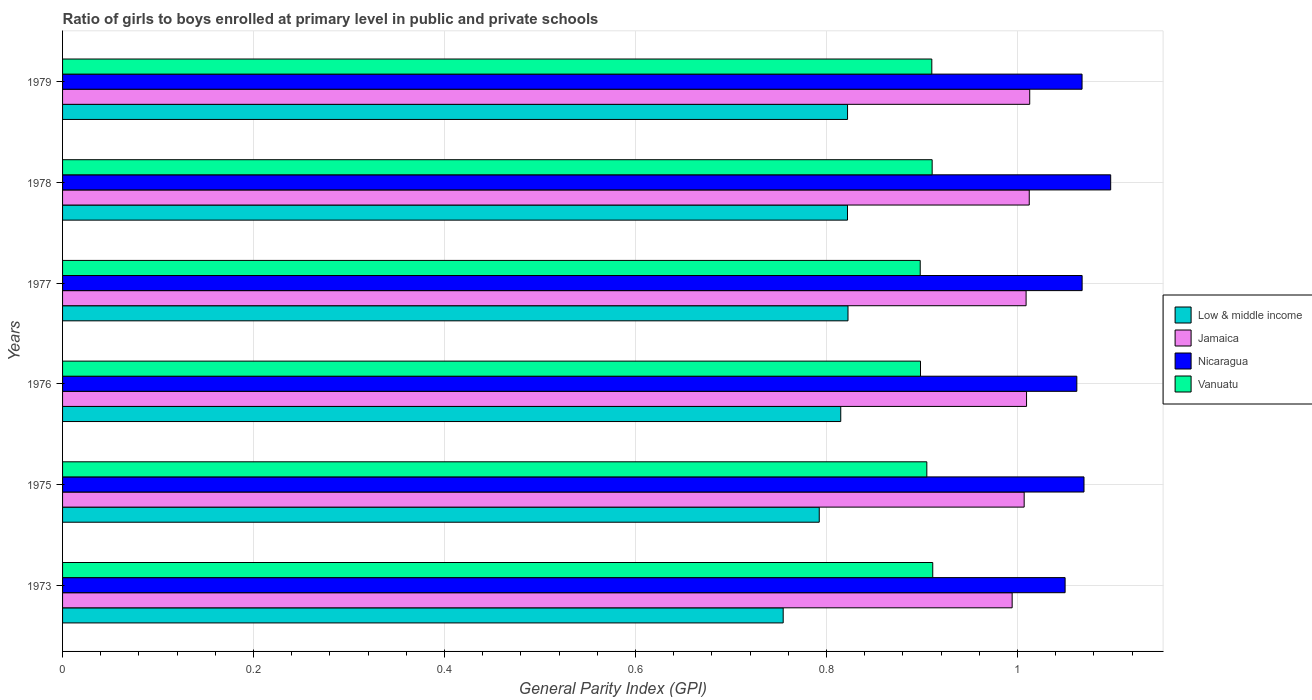How many different coloured bars are there?
Your response must be concise. 4. How many bars are there on the 1st tick from the top?
Ensure brevity in your answer.  4. What is the label of the 3rd group of bars from the top?
Keep it short and to the point. 1977. In how many cases, is the number of bars for a given year not equal to the number of legend labels?
Provide a short and direct response. 0. What is the general parity index in Nicaragua in 1975?
Offer a terse response. 1.07. Across all years, what is the maximum general parity index in Jamaica?
Offer a very short reply. 1.01. Across all years, what is the minimum general parity index in Low & middle income?
Your answer should be compact. 0.75. In which year was the general parity index in Vanuatu maximum?
Your answer should be very brief. 1973. In which year was the general parity index in Vanuatu minimum?
Make the answer very short. 1977. What is the total general parity index in Nicaragua in the graph?
Your answer should be compact. 6.41. What is the difference between the general parity index in Nicaragua in 1973 and that in 1975?
Ensure brevity in your answer.  -0.02. What is the difference between the general parity index in Vanuatu in 1979 and the general parity index in Low & middle income in 1976?
Your answer should be very brief. 0.1. What is the average general parity index in Low & middle income per year?
Keep it short and to the point. 0.8. In the year 1975, what is the difference between the general parity index in Nicaragua and general parity index in Jamaica?
Offer a terse response. 0.06. What is the ratio of the general parity index in Low & middle income in 1975 to that in 1977?
Provide a succinct answer. 0.96. Is the difference between the general parity index in Nicaragua in 1975 and 1977 greater than the difference between the general parity index in Jamaica in 1975 and 1977?
Give a very brief answer. Yes. What is the difference between the highest and the second highest general parity index in Jamaica?
Your answer should be very brief. 0. What is the difference between the highest and the lowest general parity index in Low & middle income?
Offer a very short reply. 0.07. In how many years, is the general parity index in Nicaragua greater than the average general parity index in Nicaragua taken over all years?
Your answer should be compact. 2. Is the sum of the general parity index in Vanuatu in 1976 and 1977 greater than the maximum general parity index in Jamaica across all years?
Your answer should be compact. Yes. What does the 1st bar from the top in 1979 represents?
Offer a very short reply. Vanuatu. How many bars are there?
Offer a terse response. 24. Are all the bars in the graph horizontal?
Provide a succinct answer. Yes. How many years are there in the graph?
Your answer should be very brief. 6. Does the graph contain any zero values?
Provide a short and direct response. No. How many legend labels are there?
Ensure brevity in your answer.  4. How are the legend labels stacked?
Ensure brevity in your answer.  Vertical. What is the title of the graph?
Provide a succinct answer. Ratio of girls to boys enrolled at primary level in public and private schools. What is the label or title of the X-axis?
Give a very brief answer. General Parity Index (GPI). What is the General Parity Index (GPI) of Low & middle income in 1973?
Offer a terse response. 0.75. What is the General Parity Index (GPI) of Jamaica in 1973?
Provide a short and direct response. 0.99. What is the General Parity Index (GPI) in Nicaragua in 1973?
Your answer should be compact. 1.05. What is the General Parity Index (GPI) of Vanuatu in 1973?
Make the answer very short. 0.91. What is the General Parity Index (GPI) in Low & middle income in 1975?
Your answer should be very brief. 0.79. What is the General Parity Index (GPI) in Jamaica in 1975?
Provide a succinct answer. 1.01. What is the General Parity Index (GPI) in Nicaragua in 1975?
Make the answer very short. 1.07. What is the General Parity Index (GPI) in Vanuatu in 1975?
Provide a short and direct response. 0.91. What is the General Parity Index (GPI) of Low & middle income in 1976?
Keep it short and to the point. 0.81. What is the General Parity Index (GPI) of Jamaica in 1976?
Your response must be concise. 1.01. What is the General Parity Index (GPI) in Nicaragua in 1976?
Your response must be concise. 1.06. What is the General Parity Index (GPI) of Vanuatu in 1976?
Your answer should be compact. 0.9. What is the General Parity Index (GPI) in Low & middle income in 1977?
Provide a short and direct response. 0.82. What is the General Parity Index (GPI) in Jamaica in 1977?
Provide a succinct answer. 1.01. What is the General Parity Index (GPI) in Nicaragua in 1977?
Your response must be concise. 1.07. What is the General Parity Index (GPI) of Vanuatu in 1977?
Your response must be concise. 0.9. What is the General Parity Index (GPI) in Low & middle income in 1978?
Make the answer very short. 0.82. What is the General Parity Index (GPI) in Jamaica in 1978?
Offer a terse response. 1.01. What is the General Parity Index (GPI) of Nicaragua in 1978?
Give a very brief answer. 1.1. What is the General Parity Index (GPI) in Vanuatu in 1978?
Provide a short and direct response. 0.91. What is the General Parity Index (GPI) in Low & middle income in 1979?
Keep it short and to the point. 0.82. What is the General Parity Index (GPI) of Jamaica in 1979?
Your answer should be very brief. 1.01. What is the General Parity Index (GPI) in Nicaragua in 1979?
Offer a terse response. 1.07. What is the General Parity Index (GPI) in Vanuatu in 1979?
Your response must be concise. 0.91. Across all years, what is the maximum General Parity Index (GPI) in Low & middle income?
Offer a very short reply. 0.82. Across all years, what is the maximum General Parity Index (GPI) of Jamaica?
Keep it short and to the point. 1.01. Across all years, what is the maximum General Parity Index (GPI) in Nicaragua?
Provide a short and direct response. 1.1. Across all years, what is the maximum General Parity Index (GPI) of Vanuatu?
Ensure brevity in your answer.  0.91. Across all years, what is the minimum General Parity Index (GPI) in Low & middle income?
Your response must be concise. 0.75. Across all years, what is the minimum General Parity Index (GPI) of Jamaica?
Offer a very short reply. 0.99. Across all years, what is the minimum General Parity Index (GPI) in Nicaragua?
Provide a short and direct response. 1.05. Across all years, what is the minimum General Parity Index (GPI) of Vanuatu?
Your answer should be very brief. 0.9. What is the total General Parity Index (GPI) of Low & middle income in the graph?
Your answer should be very brief. 4.83. What is the total General Parity Index (GPI) in Jamaica in the graph?
Give a very brief answer. 6.05. What is the total General Parity Index (GPI) in Nicaragua in the graph?
Your response must be concise. 6.41. What is the total General Parity Index (GPI) of Vanuatu in the graph?
Your response must be concise. 5.43. What is the difference between the General Parity Index (GPI) of Low & middle income in 1973 and that in 1975?
Keep it short and to the point. -0.04. What is the difference between the General Parity Index (GPI) of Jamaica in 1973 and that in 1975?
Your response must be concise. -0.01. What is the difference between the General Parity Index (GPI) of Nicaragua in 1973 and that in 1975?
Offer a terse response. -0.02. What is the difference between the General Parity Index (GPI) of Vanuatu in 1973 and that in 1975?
Your answer should be very brief. 0.01. What is the difference between the General Parity Index (GPI) in Low & middle income in 1973 and that in 1976?
Offer a very short reply. -0.06. What is the difference between the General Parity Index (GPI) in Jamaica in 1973 and that in 1976?
Make the answer very short. -0.02. What is the difference between the General Parity Index (GPI) in Nicaragua in 1973 and that in 1976?
Ensure brevity in your answer.  -0.01. What is the difference between the General Parity Index (GPI) in Vanuatu in 1973 and that in 1976?
Provide a short and direct response. 0.01. What is the difference between the General Parity Index (GPI) of Low & middle income in 1973 and that in 1977?
Offer a terse response. -0.07. What is the difference between the General Parity Index (GPI) in Jamaica in 1973 and that in 1977?
Ensure brevity in your answer.  -0.01. What is the difference between the General Parity Index (GPI) in Nicaragua in 1973 and that in 1977?
Ensure brevity in your answer.  -0.02. What is the difference between the General Parity Index (GPI) in Vanuatu in 1973 and that in 1977?
Your answer should be very brief. 0.01. What is the difference between the General Parity Index (GPI) in Low & middle income in 1973 and that in 1978?
Your response must be concise. -0.07. What is the difference between the General Parity Index (GPI) in Jamaica in 1973 and that in 1978?
Give a very brief answer. -0.02. What is the difference between the General Parity Index (GPI) in Nicaragua in 1973 and that in 1978?
Your answer should be very brief. -0.05. What is the difference between the General Parity Index (GPI) of Vanuatu in 1973 and that in 1978?
Your response must be concise. 0. What is the difference between the General Parity Index (GPI) of Low & middle income in 1973 and that in 1979?
Your response must be concise. -0.07. What is the difference between the General Parity Index (GPI) of Jamaica in 1973 and that in 1979?
Keep it short and to the point. -0.02. What is the difference between the General Parity Index (GPI) of Nicaragua in 1973 and that in 1979?
Offer a very short reply. -0.02. What is the difference between the General Parity Index (GPI) in Low & middle income in 1975 and that in 1976?
Make the answer very short. -0.02. What is the difference between the General Parity Index (GPI) in Jamaica in 1975 and that in 1976?
Your answer should be very brief. -0. What is the difference between the General Parity Index (GPI) of Nicaragua in 1975 and that in 1976?
Offer a terse response. 0.01. What is the difference between the General Parity Index (GPI) of Vanuatu in 1975 and that in 1976?
Your response must be concise. 0.01. What is the difference between the General Parity Index (GPI) of Low & middle income in 1975 and that in 1977?
Make the answer very short. -0.03. What is the difference between the General Parity Index (GPI) of Jamaica in 1975 and that in 1977?
Provide a succinct answer. -0. What is the difference between the General Parity Index (GPI) of Nicaragua in 1975 and that in 1977?
Provide a succinct answer. 0. What is the difference between the General Parity Index (GPI) of Vanuatu in 1975 and that in 1977?
Provide a short and direct response. 0.01. What is the difference between the General Parity Index (GPI) of Low & middle income in 1975 and that in 1978?
Give a very brief answer. -0.03. What is the difference between the General Parity Index (GPI) of Jamaica in 1975 and that in 1978?
Your response must be concise. -0.01. What is the difference between the General Parity Index (GPI) of Nicaragua in 1975 and that in 1978?
Ensure brevity in your answer.  -0.03. What is the difference between the General Parity Index (GPI) in Vanuatu in 1975 and that in 1978?
Offer a terse response. -0.01. What is the difference between the General Parity Index (GPI) of Low & middle income in 1975 and that in 1979?
Offer a very short reply. -0.03. What is the difference between the General Parity Index (GPI) of Jamaica in 1975 and that in 1979?
Ensure brevity in your answer.  -0.01. What is the difference between the General Parity Index (GPI) in Nicaragua in 1975 and that in 1979?
Provide a short and direct response. 0. What is the difference between the General Parity Index (GPI) of Vanuatu in 1975 and that in 1979?
Provide a short and direct response. -0.01. What is the difference between the General Parity Index (GPI) of Low & middle income in 1976 and that in 1977?
Make the answer very short. -0.01. What is the difference between the General Parity Index (GPI) in Nicaragua in 1976 and that in 1977?
Provide a short and direct response. -0.01. What is the difference between the General Parity Index (GPI) in Vanuatu in 1976 and that in 1977?
Your answer should be very brief. 0. What is the difference between the General Parity Index (GPI) in Low & middle income in 1976 and that in 1978?
Your answer should be compact. -0.01. What is the difference between the General Parity Index (GPI) in Jamaica in 1976 and that in 1978?
Offer a very short reply. -0. What is the difference between the General Parity Index (GPI) in Nicaragua in 1976 and that in 1978?
Offer a very short reply. -0.04. What is the difference between the General Parity Index (GPI) of Vanuatu in 1976 and that in 1978?
Make the answer very short. -0.01. What is the difference between the General Parity Index (GPI) of Low & middle income in 1976 and that in 1979?
Ensure brevity in your answer.  -0.01. What is the difference between the General Parity Index (GPI) in Jamaica in 1976 and that in 1979?
Keep it short and to the point. -0. What is the difference between the General Parity Index (GPI) in Nicaragua in 1976 and that in 1979?
Keep it short and to the point. -0.01. What is the difference between the General Parity Index (GPI) of Vanuatu in 1976 and that in 1979?
Ensure brevity in your answer.  -0.01. What is the difference between the General Parity Index (GPI) of Jamaica in 1977 and that in 1978?
Keep it short and to the point. -0. What is the difference between the General Parity Index (GPI) in Nicaragua in 1977 and that in 1978?
Your answer should be very brief. -0.03. What is the difference between the General Parity Index (GPI) of Vanuatu in 1977 and that in 1978?
Your response must be concise. -0.01. What is the difference between the General Parity Index (GPI) in Jamaica in 1977 and that in 1979?
Ensure brevity in your answer.  -0. What is the difference between the General Parity Index (GPI) of Nicaragua in 1977 and that in 1979?
Offer a terse response. 0. What is the difference between the General Parity Index (GPI) in Vanuatu in 1977 and that in 1979?
Provide a succinct answer. -0.01. What is the difference between the General Parity Index (GPI) of Low & middle income in 1978 and that in 1979?
Your response must be concise. -0. What is the difference between the General Parity Index (GPI) in Jamaica in 1978 and that in 1979?
Your response must be concise. -0. What is the difference between the General Parity Index (GPI) in Nicaragua in 1978 and that in 1979?
Your answer should be very brief. 0.03. What is the difference between the General Parity Index (GPI) in Low & middle income in 1973 and the General Parity Index (GPI) in Jamaica in 1975?
Keep it short and to the point. -0.25. What is the difference between the General Parity Index (GPI) of Low & middle income in 1973 and the General Parity Index (GPI) of Nicaragua in 1975?
Give a very brief answer. -0.32. What is the difference between the General Parity Index (GPI) in Low & middle income in 1973 and the General Parity Index (GPI) in Vanuatu in 1975?
Offer a terse response. -0.15. What is the difference between the General Parity Index (GPI) in Jamaica in 1973 and the General Parity Index (GPI) in Nicaragua in 1975?
Offer a terse response. -0.08. What is the difference between the General Parity Index (GPI) in Jamaica in 1973 and the General Parity Index (GPI) in Vanuatu in 1975?
Provide a short and direct response. 0.09. What is the difference between the General Parity Index (GPI) of Nicaragua in 1973 and the General Parity Index (GPI) of Vanuatu in 1975?
Ensure brevity in your answer.  0.14. What is the difference between the General Parity Index (GPI) in Low & middle income in 1973 and the General Parity Index (GPI) in Jamaica in 1976?
Give a very brief answer. -0.25. What is the difference between the General Parity Index (GPI) in Low & middle income in 1973 and the General Parity Index (GPI) in Nicaragua in 1976?
Provide a short and direct response. -0.31. What is the difference between the General Parity Index (GPI) of Low & middle income in 1973 and the General Parity Index (GPI) of Vanuatu in 1976?
Your answer should be very brief. -0.14. What is the difference between the General Parity Index (GPI) in Jamaica in 1973 and the General Parity Index (GPI) in Nicaragua in 1976?
Give a very brief answer. -0.07. What is the difference between the General Parity Index (GPI) in Jamaica in 1973 and the General Parity Index (GPI) in Vanuatu in 1976?
Offer a terse response. 0.1. What is the difference between the General Parity Index (GPI) in Nicaragua in 1973 and the General Parity Index (GPI) in Vanuatu in 1976?
Your response must be concise. 0.15. What is the difference between the General Parity Index (GPI) of Low & middle income in 1973 and the General Parity Index (GPI) of Jamaica in 1977?
Your answer should be compact. -0.25. What is the difference between the General Parity Index (GPI) of Low & middle income in 1973 and the General Parity Index (GPI) of Nicaragua in 1977?
Provide a succinct answer. -0.31. What is the difference between the General Parity Index (GPI) in Low & middle income in 1973 and the General Parity Index (GPI) in Vanuatu in 1977?
Your answer should be very brief. -0.14. What is the difference between the General Parity Index (GPI) of Jamaica in 1973 and the General Parity Index (GPI) of Nicaragua in 1977?
Your answer should be very brief. -0.07. What is the difference between the General Parity Index (GPI) in Jamaica in 1973 and the General Parity Index (GPI) in Vanuatu in 1977?
Your response must be concise. 0.1. What is the difference between the General Parity Index (GPI) of Nicaragua in 1973 and the General Parity Index (GPI) of Vanuatu in 1977?
Give a very brief answer. 0.15. What is the difference between the General Parity Index (GPI) of Low & middle income in 1973 and the General Parity Index (GPI) of Jamaica in 1978?
Provide a short and direct response. -0.26. What is the difference between the General Parity Index (GPI) of Low & middle income in 1973 and the General Parity Index (GPI) of Nicaragua in 1978?
Your answer should be very brief. -0.34. What is the difference between the General Parity Index (GPI) of Low & middle income in 1973 and the General Parity Index (GPI) of Vanuatu in 1978?
Keep it short and to the point. -0.16. What is the difference between the General Parity Index (GPI) in Jamaica in 1973 and the General Parity Index (GPI) in Nicaragua in 1978?
Provide a succinct answer. -0.1. What is the difference between the General Parity Index (GPI) of Jamaica in 1973 and the General Parity Index (GPI) of Vanuatu in 1978?
Offer a very short reply. 0.08. What is the difference between the General Parity Index (GPI) of Nicaragua in 1973 and the General Parity Index (GPI) of Vanuatu in 1978?
Your response must be concise. 0.14. What is the difference between the General Parity Index (GPI) of Low & middle income in 1973 and the General Parity Index (GPI) of Jamaica in 1979?
Offer a very short reply. -0.26. What is the difference between the General Parity Index (GPI) in Low & middle income in 1973 and the General Parity Index (GPI) in Nicaragua in 1979?
Make the answer very short. -0.31. What is the difference between the General Parity Index (GPI) in Low & middle income in 1973 and the General Parity Index (GPI) in Vanuatu in 1979?
Provide a short and direct response. -0.16. What is the difference between the General Parity Index (GPI) of Jamaica in 1973 and the General Parity Index (GPI) of Nicaragua in 1979?
Give a very brief answer. -0.07. What is the difference between the General Parity Index (GPI) in Jamaica in 1973 and the General Parity Index (GPI) in Vanuatu in 1979?
Provide a short and direct response. 0.08. What is the difference between the General Parity Index (GPI) in Nicaragua in 1973 and the General Parity Index (GPI) in Vanuatu in 1979?
Provide a short and direct response. 0.14. What is the difference between the General Parity Index (GPI) of Low & middle income in 1975 and the General Parity Index (GPI) of Jamaica in 1976?
Your answer should be very brief. -0.22. What is the difference between the General Parity Index (GPI) in Low & middle income in 1975 and the General Parity Index (GPI) in Nicaragua in 1976?
Your answer should be compact. -0.27. What is the difference between the General Parity Index (GPI) in Low & middle income in 1975 and the General Parity Index (GPI) in Vanuatu in 1976?
Make the answer very short. -0.11. What is the difference between the General Parity Index (GPI) of Jamaica in 1975 and the General Parity Index (GPI) of Nicaragua in 1976?
Offer a terse response. -0.06. What is the difference between the General Parity Index (GPI) of Jamaica in 1975 and the General Parity Index (GPI) of Vanuatu in 1976?
Make the answer very short. 0.11. What is the difference between the General Parity Index (GPI) in Nicaragua in 1975 and the General Parity Index (GPI) in Vanuatu in 1976?
Offer a very short reply. 0.17. What is the difference between the General Parity Index (GPI) in Low & middle income in 1975 and the General Parity Index (GPI) in Jamaica in 1977?
Keep it short and to the point. -0.22. What is the difference between the General Parity Index (GPI) in Low & middle income in 1975 and the General Parity Index (GPI) in Nicaragua in 1977?
Keep it short and to the point. -0.28. What is the difference between the General Parity Index (GPI) of Low & middle income in 1975 and the General Parity Index (GPI) of Vanuatu in 1977?
Offer a terse response. -0.11. What is the difference between the General Parity Index (GPI) in Jamaica in 1975 and the General Parity Index (GPI) in Nicaragua in 1977?
Keep it short and to the point. -0.06. What is the difference between the General Parity Index (GPI) in Jamaica in 1975 and the General Parity Index (GPI) in Vanuatu in 1977?
Give a very brief answer. 0.11. What is the difference between the General Parity Index (GPI) in Nicaragua in 1975 and the General Parity Index (GPI) in Vanuatu in 1977?
Ensure brevity in your answer.  0.17. What is the difference between the General Parity Index (GPI) of Low & middle income in 1975 and the General Parity Index (GPI) of Jamaica in 1978?
Provide a succinct answer. -0.22. What is the difference between the General Parity Index (GPI) of Low & middle income in 1975 and the General Parity Index (GPI) of Nicaragua in 1978?
Provide a succinct answer. -0.31. What is the difference between the General Parity Index (GPI) in Low & middle income in 1975 and the General Parity Index (GPI) in Vanuatu in 1978?
Ensure brevity in your answer.  -0.12. What is the difference between the General Parity Index (GPI) of Jamaica in 1975 and the General Parity Index (GPI) of Nicaragua in 1978?
Give a very brief answer. -0.09. What is the difference between the General Parity Index (GPI) in Jamaica in 1975 and the General Parity Index (GPI) in Vanuatu in 1978?
Make the answer very short. 0.1. What is the difference between the General Parity Index (GPI) in Nicaragua in 1975 and the General Parity Index (GPI) in Vanuatu in 1978?
Keep it short and to the point. 0.16. What is the difference between the General Parity Index (GPI) in Low & middle income in 1975 and the General Parity Index (GPI) in Jamaica in 1979?
Provide a succinct answer. -0.22. What is the difference between the General Parity Index (GPI) of Low & middle income in 1975 and the General Parity Index (GPI) of Nicaragua in 1979?
Your response must be concise. -0.28. What is the difference between the General Parity Index (GPI) of Low & middle income in 1975 and the General Parity Index (GPI) of Vanuatu in 1979?
Provide a short and direct response. -0.12. What is the difference between the General Parity Index (GPI) in Jamaica in 1975 and the General Parity Index (GPI) in Nicaragua in 1979?
Your answer should be very brief. -0.06. What is the difference between the General Parity Index (GPI) in Jamaica in 1975 and the General Parity Index (GPI) in Vanuatu in 1979?
Keep it short and to the point. 0.1. What is the difference between the General Parity Index (GPI) in Nicaragua in 1975 and the General Parity Index (GPI) in Vanuatu in 1979?
Your answer should be very brief. 0.16. What is the difference between the General Parity Index (GPI) of Low & middle income in 1976 and the General Parity Index (GPI) of Jamaica in 1977?
Your response must be concise. -0.19. What is the difference between the General Parity Index (GPI) in Low & middle income in 1976 and the General Parity Index (GPI) in Nicaragua in 1977?
Provide a short and direct response. -0.25. What is the difference between the General Parity Index (GPI) of Low & middle income in 1976 and the General Parity Index (GPI) of Vanuatu in 1977?
Keep it short and to the point. -0.08. What is the difference between the General Parity Index (GPI) in Jamaica in 1976 and the General Parity Index (GPI) in Nicaragua in 1977?
Give a very brief answer. -0.06. What is the difference between the General Parity Index (GPI) of Jamaica in 1976 and the General Parity Index (GPI) of Vanuatu in 1977?
Your answer should be very brief. 0.11. What is the difference between the General Parity Index (GPI) of Nicaragua in 1976 and the General Parity Index (GPI) of Vanuatu in 1977?
Your answer should be very brief. 0.16. What is the difference between the General Parity Index (GPI) of Low & middle income in 1976 and the General Parity Index (GPI) of Jamaica in 1978?
Your response must be concise. -0.2. What is the difference between the General Parity Index (GPI) in Low & middle income in 1976 and the General Parity Index (GPI) in Nicaragua in 1978?
Offer a very short reply. -0.28. What is the difference between the General Parity Index (GPI) of Low & middle income in 1976 and the General Parity Index (GPI) of Vanuatu in 1978?
Your answer should be compact. -0.1. What is the difference between the General Parity Index (GPI) in Jamaica in 1976 and the General Parity Index (GPI) in Nicaragua in 1978?
Ensure brevity in your answer.  -0.09. What is the difference between the General Parity Index (GPI) in Jamaica in 1976 and the General Parity Index (GPI) in Vanuatu in 1978?
Your answer should be compact. 0.1. What is the difference between the General Parity Index (GPI) in Nicaragua in 1976 and the General Parity Index (GPI) in Vanuatu in 1978?
Provide a short and direct response. 0.15. What is the difference between the General Parity Index (GPI) of Low & middle income in 1976 and the General Parity Index (GPI) of Jamaica in 1979?
Ensure brevity in your answer.  -0.2. What is the difference between the General Parity Index (GPI) of Low & middle income in 1976 and the General Parity Index (GPI) of Nicaragua in 1979?
Your response must be concise. -0.25. What is the difference between the General Parity Index (GPI) in Low & middle income in 1976 and the General Parity Index (GPI) in Vanuatu in 1979?
Your answer should be compact. -0.1. What is the difference between the General Parity Index (GPI) in Jamaica in 1976 and the General Parity Index (GPI) in Nicaragua in 1979?
Your response must be concise. -0.06. What is the difference between the General Parity Index (GPI) of Jamaica in 1976 and the General Parity Index (GPI) of Vanuatu in 1979?
Provide a short and direct response. 0.1. What is the difference between the General Parity Index (GPI) in Nicaragua in 1976 and the General Parity Index (GPI) in Vanuatu in 1979?
Offer a very short reply. 0.15. What is the difference between the General Parity Index (GPI) of Low & middle income in 1977 and the General Parity Index (GPI) of Jamaica in 1978?
Provide a short and direct response. -0.19. What is the difference between the General Parity Index (GPI) in Low & middle income in 1977 and the General Parity Index (GPI) in Nicaragua in 1978?
Your response must be concise. -0.28. What is the difference between the General Parity Index (GPI) in Low & middle income in 1977 and the General Parity Index (GPI) in Vanuatu in 1978?
Your answer should be compact. -0.09. What is the difference between the General Parity Index (GPI) of Jamaica in 1977 and the General Parity Index (GPI) of Nicaragua in 1978?
Your answer should be compact. -0.09. What is the difference between the General Parity Index (GPI) in Jamaica in 1977 and the General Parity Index (GPI) in Vanuatu in 1978?
Make the answer very short. 0.1. What is the difference between the General Parity Index (GPI) in Nicaragua in 1977 and the General Parity Index (GPI) in Vanuatu in 1978?
Make the answer very short. 0.16. What is the difference between the General Parity Index (GPI) of Low & middle income in 1977 and the General Parity Index (GPI) of Jamaica in 1979?
Offer a very short reply. -0.19. What is the difference between the General Parity Index (GPI) in Low & middle income in 1977 and the General Parity Index (GPI) in Nicaragua in 1979?
Your answer should be compact. -0.25. What is the difference between the General Parity Index (GPI) of Low & middle income in 1977 and the General Parity Index (GPI) of Vanuatu in 1979?
Your response must be concise. -0.09. What is the difference between the General Parity Index (GPI) in Jamaica in 1977 and the General Parity Index (GPI) in Nicaragua in 1979?
Keep it short and to the point. -0.06. What is the difference between the General Parity Index (GPI) in Jamaica in 1977 and the General Parity Index (GPI) in Vanuatu in 1979?
Offer a very short reply. 0.1. What is the difference between the General Parity Index (GPI) in Nicaragua in 1977 and the General Parity Index (GPI) in Vanuatu in 1979?
Offer a terse response. 0.16. What is the difference between the General Parity Index (GPI) in Low & middle income in 1978 and the General Parity Index (GPI) in Jamaica in 1979?
Make the answer very short. -0.19. What is the difference between the General Parity Index (GPI) in Low & middle income in 1978 and the General Parity Index (GPI) in Nicaragua in 1979?
Provide a short and direct response. -0.25. What is the difference between the General Parity Index (GPI) in Low & middle income in 1978 and the General Parity Index (GPI) in Vanuatu in 1979?
Make the answer very short. -0.09. What is the difference between the General Parity Index (GPI) in Jamaica in 1978 and the General Parity Index (GPI) in Nicaragua in 1979?
Keep it short and to the point. -0.06. What is the difference between the General Parity Index (GPI) of Jamaica in 1978 and the General Parity Index (GPI) of Vanuatu in 1979?
Your answer should be compact. 0.1. What is the difference between the General Parity Index (GPI) of Nicaragua in 1978 and the General Parity Index (GPI) of Vanuatu in 1979?
Your answer should be very brief. 0.19. What is the average General Parity Index (GPI) in Low & middle income per year?
Ensure brevity in your answer.  0.8. What is the average General Parity Index (GPI) in Jamaica per year?
Your answer should be compact. 1.01. What is the average General Parity Index (GPI) in Nicaragua per year?
Your response must be concise. 1.07. What is the average General Parity Index (GPI) of Vanuatu per year?
Ensure brevity in your answer.  0.91. In the year 1973, what is the difference between the General Parity Index (GPI) in Low & middle income and General Parity Index (GPI) in Jamaica?
Offer a terse response. -0.24. In the year 1973, what is the difference between the General Parity Index (GPI) of Low & middle income and General Parity Index (GPI) of Nicaragua?
Give a very brief answer. -0.3. In the year 1973, what is the difference between the General Parity Index (GPI) in Low & middle income and General Parity Index (GPI) in Vanuatu?
Your response must be concise. -0.16. In the year 1973, what is the difference between the General Parity Index (GPI) in Jamaica and General Parity Index (GPI) in Nicaragua?
Give a very brief answer. -0.06. In the year 1973, what is the difference between the General Parity Index (GPI) in Jamaica and General Parity Index (GPI) in Vanuatu?
Offer a terse response. 0.08. In the year 1973, what is the difference between the General Parity Index (GPI) in Nicaragua and General Parity Index (GPI) in Vanuatu?
Ensure brevity in your answer.  0.14. In the year 1975, what is the difference between the General Parity Index (GPI) of Low & middle income and General Parity Index (GPI) of Jamaica?
Keep it short and to the point. -0.21. In the year 1975, what is the difference between the General Parity Index (GPI) of Low & middle income and General Parity Index (GPI) of Nicaragua?
Keep it short and to the point. -0.28. In the year 1975, what is the difference between the General Parity Index (GPI) in Low & middle income and General Parity Index (GPI) in Vanuatu?
Provide a succinct answer. -0.11. In the year 1975, what is the difference between the General Parity Index (GPI) of Jamaica and General Parity Index (GPI) of Nicaragua?
Offer a terse response. -0.06. In the year 1975, what is the difference between the General Parity Index (GPI) in Jamaica and General Parity Index (GPI) in Vanuatu?
Offer a terse response. 0.1. In the year 1975, what is the difference between the General Parity Index (GPI) in Nicaragua and General Parity Index (GPI) in Vanuatu?
Give a very brief answer. 0.16. In the year 1976, what is the difference between the General Parity Index (GPI) of Low & middle income and General Parity Index (GPI) of Jamaica?
Your answer should be very brief. -0.19. In the year 1976, what is the difference between the General Parity Index (GPI) of Low & middle income and General Parity Index (GPI) of Nicaragua?
Make the answer very short. -0.25. In the year 1976, what is the difference between the General Parity Index (GPI) in Low & middle income and General Parity Index (GPI) in Vanuatu?
Give a very brief answer. -0.08. In the year 1976, what is the difference between the General Parity Index (GPI) in Jamaica and General Parity Index (GPI) in Nicaragua?
Offer a terse response. -0.05. In the year 1976, what is the difference between the General Parity Index (GPI) in Jamaica and General Parity Index (GPI) in Vanuatu?
Your answer should be compact. 0.11. In the year 1976, what is the difference between the General Parity Index (GPI) in Nicaragua and General Parity Index (GPI) in Vanuatu?
Make the answer very short. 0.16. In the year 1977, what is the difference between the General Parity Index (GPI) of Low & middle income and General Parity Index (GPI) of Jamaica?
Offer a terse response. -0.19. In the year 1977, what is the difference between the General Parity Index (GPI) of Low & middle income and General Parity Index (GPI) of Nicaragua?
Offer a terse response. -0.25. In the year 1977, what is the difference between the General Parity Index (GPI) in Low & middle income and General Parity Index (GPI) in Vanuatu?
Offer a terse response. -0.08. In the year 1977, what is the difference between the General Parity Index (GPI) in Jamaica and General Parity Index (GPI) in Nicaragua?
Your answer should be very brief. -0.06. In the year 1977, what is the difference between the General Parity Index (GPI) of Jamaica and General Parity Index (GPI) of Vanuatu?
Keep it short and to the point. 0.11. In the year 1977, what is the difference between the General Parity Index (GPI) of Nicaragua and General Parity Index (GPI) of Vanuatu?
Keep it short and to the point. 0.17. In the year 1978, what is the difference between the General Parity Index (GPI) in Low & middle income and General Parity Index (GPI) in Jamaica?
Your answer should be compact. -0.19. In the year 1978, what is the difference between the General Parity Index (GPI) in Low & middle income and General Parity Index (GPI) in Nicaragua?
Your answer should be compact. -0.28. In the year 1978, what is the difference between the General Parity Index (GPI) in Low & middle income and General Parity Index (GPI) in Vanuatu?
Your response must be concise. -0.09. In the year 1978, what is the difference between the General Parity Index (GPI) in Jamaica and General Parity Index (GPI) in Nicaragua?
Your answer should be compact. -0.09. In the year 1978, what is the difference between the General Parity Index (GPI) in Jamaica and General Parity Index (GPI) in Vanuatu?
Provide a succinct answer. 0.1. In the year 1978, what is the difference between the General Parity Index (GPI) of Nicaragua and General Parity Index (GPI) of Vanuatu?
Keep it short and to the point. 0.19. In the year 1979, what is the difference between the General Parity Index (GPI) in Low & middle income and General Parity Index (GPI) in Jamaica?
Keep it short and to the point. -0.19. In the year 1979, what is the difference between the General Parity Index (GPI) in Low & middle income and General Parity Index (GPI) in Nicaragua?
Ensure brevity in your answer.  -0.25. In the year 1979, what is the difference between the General Parity Index (GPI) of Low & middle income and General Parity Index (GPI) of Vanuatu?
Your answer should be very brief. -0.09. In the year 1979, what is the difference between the General Parity Index (GPI) of Jamaica and General Parity Index (GPI) of Nicaragua?
Provide a short and direct response. -0.05. In the year 1979, what is the difference between the General Parity Index (GPI) in Jamaica and General Parity Index (GPI) in Vanuatu?
Offer a very short reply. 0.1. In the year 1979, what is the difference between the General Parity Index (GPI) of Nicaragua and General Parity Index (GPI) of Vanuatu?
Provide a succinct answer. 0.16. What is the ratio of the General Parity Index (GPI) of Low & middle income in 1973 to that in 1975?
Offer a terse response. 0.95. What is the ratio of the General Parity Index (GPI) of Jamaica in 1973 to that in 1975?
Give a very brief answer. 0.99. What is the ratio of the General Parity Index (GPI) of Nicaragua in 1973 to that in 1975?
Your answer should be very brief. 0.98. What is the ratio of the General Parity Index (GPI) of Low & middle income in 1973 to that in 1976?
Your answer should be compact. 0.93. What is the ratio of the General Parity Index (GPI) in Jamaica in 1973 to that in 1976?
Give a very brief answer. 0.99. What is the ratio of the General Parity Index (GPI) of Nicaragua in 1973 to that in 1976?
Keep it short and to the point. 0.99. What is the ratio of the General Parity Index (GPI) of Vanuatu in 1973 to that in 1976?
Keep it short and to the point. 1.01. What is the ratio of the General Parity Index (GPI) in Low & middle income in 1973 to that in 1977?
Offer a very short reply. 0.92. What is the ratio of the General Parity Index (GPI) in Jamaica in 1973 to that in 1977?
Your answer should be compact. 0.99. What is the ratio of the General Parity Index (GPI) of Nicaragua in 1973 to that in 1977?
Your response must be concise. 0.98. What is the ratio of the General Parity Index (GPI) of Vanuatu in 1973 to that in 1977?
Your answer should be very brief. 1.01. What is the ratio of the General Parity Index (GPI) of Low & middle income in 1973 to that in 1978?
Your answer should be very brief. 0.92. What is the ratio of the General Parity Index (GPI) in Jamaica in 1973 to that in 1978?
Offer a terse response. 0.98. What is the ratio of the General Parity Index (GPI) in Nicaragua in 1973 to that in 1978?
Offer a very short reply. 0.96. What is the ratio of the General Parity Index (GPI) in Vanuatu in 1973 to that in 1978?
Make the answer very short. 1. What is the ratio of the General Parity Index (GPI) in Low & middle income in 1973 to that in 1979?
Offer a terse response. 0.92. What is the ratio of the General Parity Index (GPI) in Jamaica in 1973 to that in 1979?
Your response must be concise. 0.98. What is the ratio of the General Parity Index (GPI) of Nicaragua in 1973 to that in 1979?
Keep it short and to the point. 0.98. What is the ratio of the General Parity Index (GPI) in Vanuatu in 1973 to that in 1979?
Your response must be concise. 1. What is the ratio of the General Parity Index (GPI) in Low & middle income in 1975 to that in 1976?
Your answer should be compact. 0.97. What is the ratio of the General Parity Index (GPI) of Jamaica in 1975 to that in 1976?
Offer a terse response. 1. What is the ratio of the General Parity Index (GPI) of Nicaragua in 1975 to that in 1976?
Provide a succinct answer. 1.01. What is the ratio of the General Parity Index (GPI) in Vanuatu in 1975 to that in 1976?
Offer a very short reply. 1.01. What is the ratio of the General Parity Index (GPI) of Low & middle income in 1975 to that in 1977?
Your response must be concise. 0.96. What is the ratio of the General Parity Index (GPI) in Jamaica in 1975 to that in 1977?
Provide a succinct answer. 1. What is the ratio of the General Parity Index (GPI) of Vanuatu in 1975 to that in 1977?
Your answer should be very brief. 1.01. What is the ratio of the General Parity Index (GPI) of Low & middle income in 1975 to that in 1978?
Give a very brief answer. 0.96. What is the ratio of the General Parity Index (GPI) of Jamaica in 1975 to that in 1978?
Make the answer very short. 0.99. What is the ratio of the General Parity Index (GPI) in Nicaragua in 1975 to that in 1978?
Offer a terse response. 0.97. What is the ratio of the General Parity Index (GPI) in Jamaica in 1975 to that in 1979?
Provide a short and direct response. 0.99. What is the ratio of the General Parity Index (GPI) in Low & middle income in 1976 to that in 1977?
Offer a terse response. 0.99. What is the ratio of the General Parity Index (GPI) in Nicaragua in 1976 to that in 1977?
Your answer should be very brief. 0.99. What is the ratio of the General Parity Index (GPI) in Low & middle income in 1976 to that in 1978?
Your response must be concise. 0.99. What is the ratio of the General Parity Index (GPI) of Jamaica in 1976 to that in 1978?
Make the answer very short. 1. What is the ratio of the General Parity Index (GPI) in Vanuatu in 1976 to that in 1978?
Your answer should be very brief. 0.99. What is the ratio of the General Parity Index (GPI) in Jamaica in 1976 to that in 1979?
Provide a short and direct response. 1. What is the ratio of the General Parity Index (GPI) of Nicaragua in 1976 to that in 1979?
Offer a very short reply. 0.99. What is the ratio of the General Parity Index (GPI) of Vanuatu in 1976 to that in 1979?
Give a very brief answer. 0.99. What is the ratio of the General Parity Index (GPI) in Low & middle income in 1977 to that in 1978?
Provide a succinct answer. 1. What is the ratio of the General Parity Index (GPI) of Nicaragua in 1977 to that in 1978?
Your answer should be very brief. 0.97. What is the ratio of the General Parity Index (GPI) in Vanuatu in 1977 to that in 1978?
Your answer should be compact. 0.99. What is the ratio of the General Parity Index (GPI) of Low & middle income in 1977 to that in 1979?
Ensure brevity in your answer.  1. What is the ratio of the General Parity Index (GPI) in Vanuatu in 1977 to that in 1979?
Keep it short and to the point. 0.99. What is the ratio of the General Parity Index (GPI) of Low & middle income in 1978 to that in 1979?
Provide a succinct answer. 1. What is the ratio of the General Parity Index (GPI) of Nicaragua in 1978 to that in 1979?
Provide a short and direct response. 1.03. What is the difference between the highest and the second highest General Parity Index (GPI) in Low & middle income?
Keep it short and to the point. 0. What is the difference between the highest and the second highest General Parity Index (GPI) of Nicaragua?
Provide a short and direct response. 0.03. What is the difference between the highest and the second highest General Parity Index (GPI) in Vanuatu?
Offer a terse response. 0. What is the difference between the highest and the lowest General Parity Index (GPI) of Low & middle income?
Keep it short and to the point. 0.07. What is the difference between the highest and the lowest General Parity Index (GPI) of Jamaica?
Offer a terse response. 0.02. What is the difference between the highest and the lowest General Parity Index (GPI) in Nicaragua?
Offer a terse response. 0.05. What is the difference between the highest and the lowest General Parity Index (GPI) of Vanuatu?
Give a very brief answer. 0.01. 